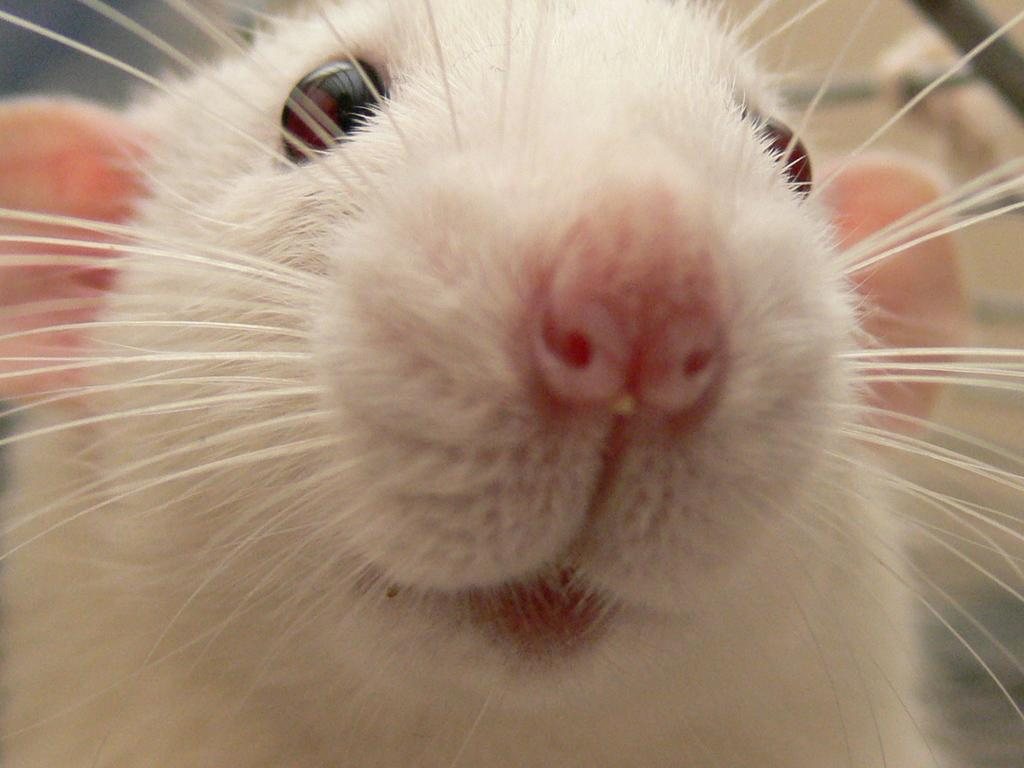What type of animal is in the image? There is a white-colored rat in the image. Can you describe the background of the image? The background of the image is blurred. What type of potato is being held by the rat in the image? There is no potato present in the image; it features a white-colored rat with a blurred background. 